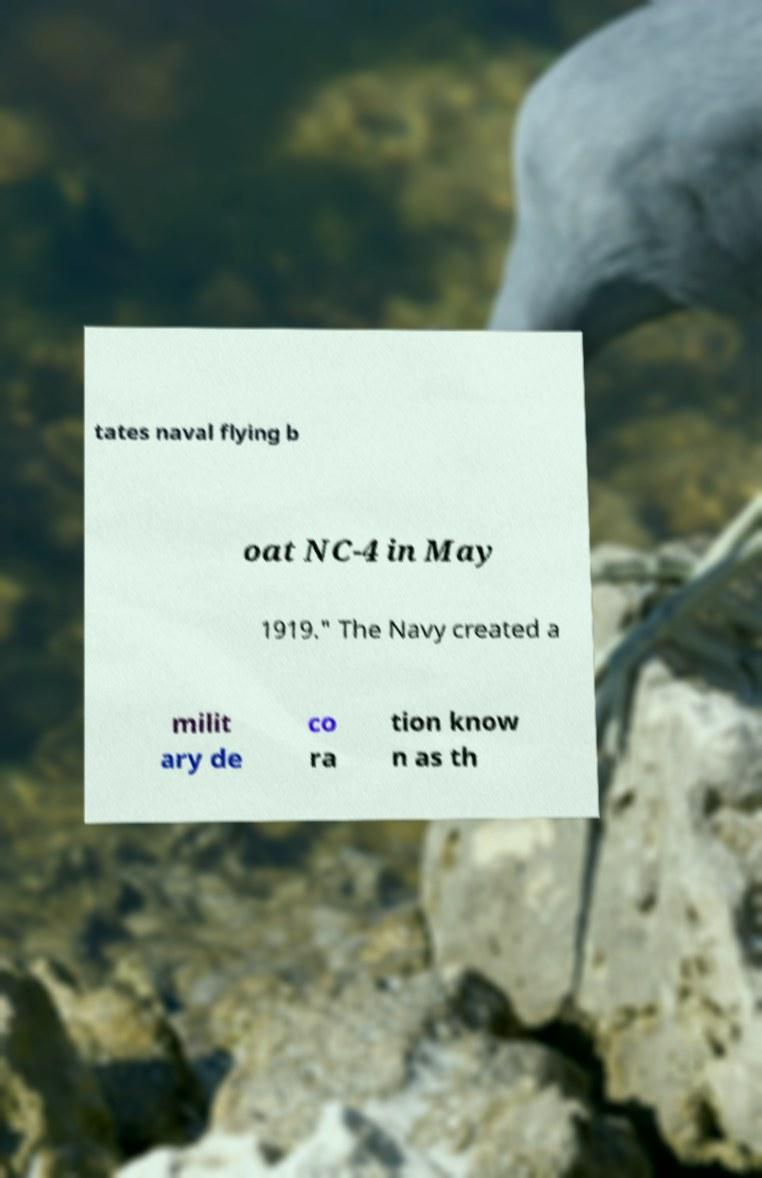Can you accurately transcribe the text from the provided image for me? tates naval flying b oat NC-4 in May 1919." The Navy created a milit ary de co ra tion know n as th 